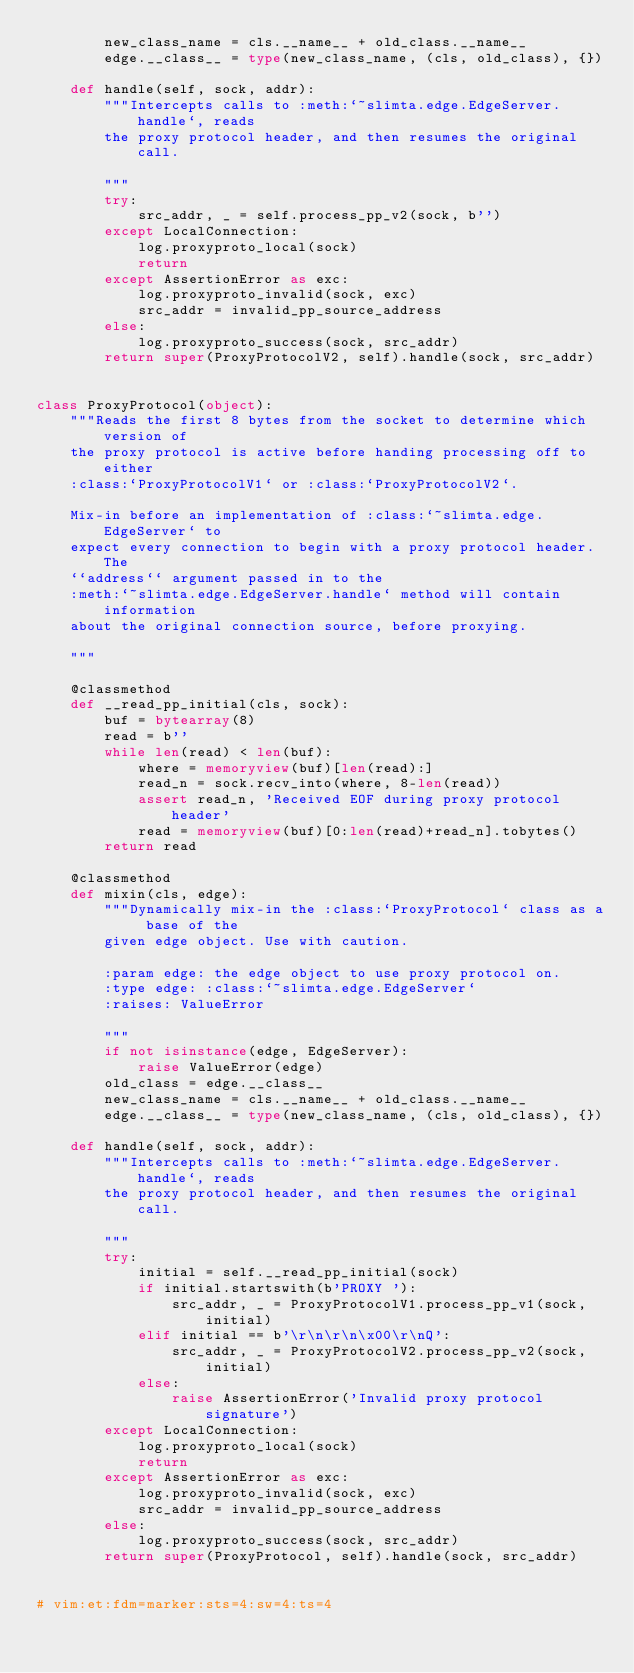<code> <loc_0><loc_0><loc_500><loc_500><_Python_>        new_class_name = cls.__name__ + old_class.__name__
        edge.__class__ = type(new_class_name, (cls, old_class), {})

    def handle(self, sock, addr):
        """Intercepts calls to :meth:`~slimta.edge.EdgeServer.handle`, reads
        the proxy protocol header, and then resumes the original call.

        """
        try:
            src_addr, _ = self.process_pp_v2(sock, b'')
        except LocalConnection:
            log.proxyproto_local(sock)
            return
        except AssertionError as exc:
            log.proxyproto_invalid(sock, exc)
            src_addr = invalid_pp_source_address
        else:
            log.proxyproto_success(sock, src_addr)
        return super(ProxyProtocolV2, self).handle(sock, src_addr)


class ProxyProtocol(object):
    """Reads the first 8 bytes from the socket to determine which version of
    the proxy protocol is active before handing processing off to either
    :class:`ProxyProtocolV1` or :class:`ProxyProtocolV2`.

    Mix-in before an implementation of :class:`~slimta.edge.EdgeServer` to
    expect every connection to begin with a proxy protocol header. The
    ``address`` argument passed in to the
    :meth:`~slimta.edge.EdgeServer.handle` method will contain information
    about the original connection source, before proxying.

    """

    @classmethod
    def __read_pp_initial(cls, sock):
        buf = bytearray(8)
        read = b''
        while len(read) < len(buf):
            where = memoryview(buf)[len(read):]
            read_n = sock.recv_into(where, 8-len(read))
            assert read_n, 'Received EOF during proxy protocol header'
            read = memoryview(buf)[0:len(read)+read_n].tobytes()
        return read

    @classmethod
    def mixin(cls, edge):
        """Dynamically mix-in the :class:`ProxyProtocol` class as a base of the
        given edge object. Use with caution.

        :param edge: the edge object to use proxy protocol on.
        :type edge: :class:`~slimta.edge.EdgeServer`
        :raises: ValueError

        """
        if not isinstance(edge, EdgeServer):
            raise ValueError(edge)
        old_class = edge.__class__
        new_class_name = cls.__name__ + old_class.__name__
        edge.__class__ = type(new_class_name, (cls, old_class), {})

    def handle(self, sock, addr):
        """Intercepts calls to :meth:`~slimta.edge.EdgeServer.handle`, reads
        the proxy protocol header, and then resumes the original call.

        """
        try:
            initial = self.__read_pp_initial(sock)
            if initial.startswith(b'PROXY '):
                src_addr, _ = ProxyProtocolV1.process_pp_v1(sock, initial)
            elif initial == b'\r\n\r\n\x00\r\nQ':
                src_addr, _ = ProxyProtocolV2.process_pp_v2(sock, initial)
            else:
                raise AssertionError('Invalid proxy protocol signature')
        except LocalConnection:
            log.proxyproto_local(sock)
            return
        except AssertionError as exc:
            log.proxyproto_invalid(sock, exc)
            src_addr = invalid_pp_source_address
        else:
            log.proxyproto_success(sock, src_addr)
        return super(ProxyProtocol, self).handle(sock, src_addr)


# vim:et:fdm=marker:sts=4:sw=4:ts=4
</code> 